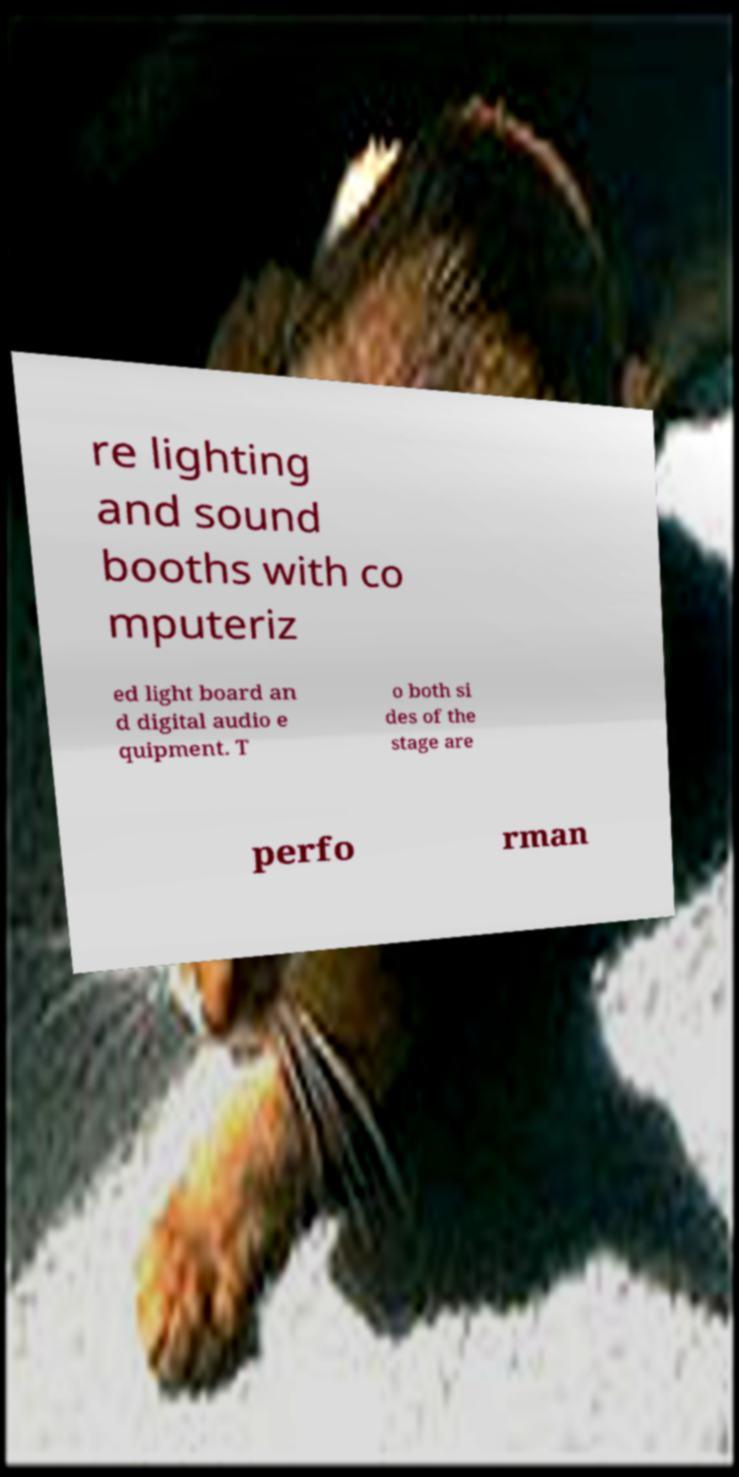Can you read and provide the text displayed in the image?This photo seems to have some interesting text. Can you extract and type it out for me? re lighting and sound booths with co mputeriz ed light board an d digital audio e quipment. T o both si des of the stage are perfo rman 